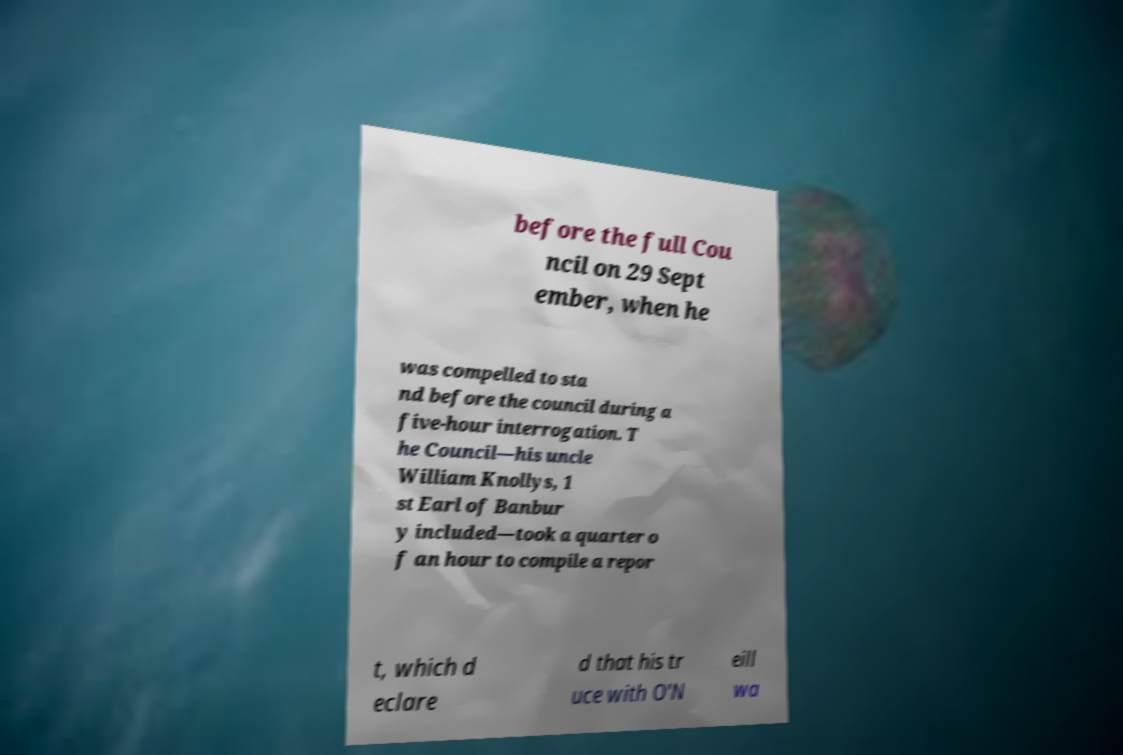Can you accurately transcribe the text from the provided image for me? before the full Cou ncil on 29 Sept ember, when he was compelled to sta nd before the council during a five-hour interrogation. T he Council—his uncle William Knollys, 1 st Earl of Banbur y included—took a quarter o f an hour to compile a repor t, which d eclare d that his tr uce with O'N eill wa 